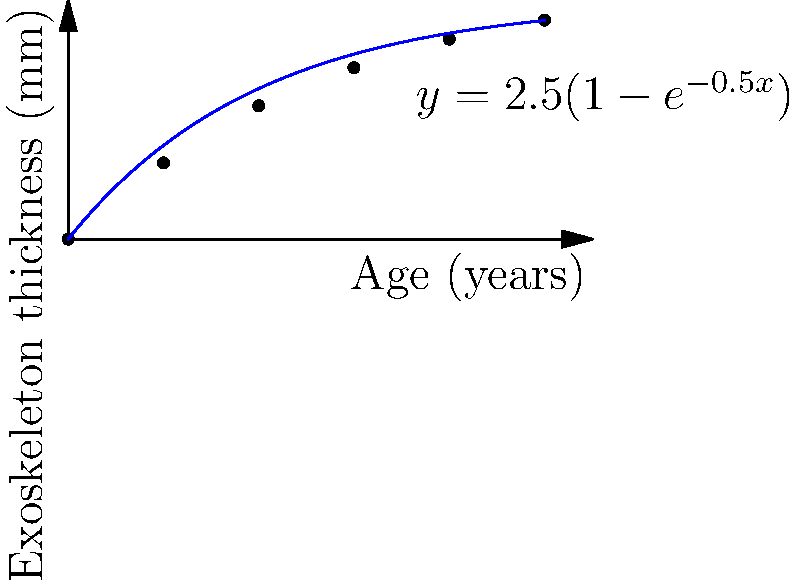Based on the graph showing the relationship between exoskeleton thickness and age in a preserved insect species, estimate the age of a specimen with an exoskeleton thickness of 1.6 mm. To estimate the age of the specimen, we need to follow these steps:

1. The graph shows a relationship between exoskeleton thickness (y-axis) and age (x-axis) for a preserved insect species.

2. The relationship is modeled by the equation $y = 2.5(1-e^{-0.5x})$, where $y$ is the exoskeleton thickness in mm and $x$ is the age in years.

3. We need to find $x$ when $y = 1.6$ mm.

4. Substituting the known values into the equation:
   $1.6 = 2.5(1-e^{-0.5x})$

5. Solving for $x$:
   $\frac{1.6}{2.5} = 1-e^{-0.5x}$
   $0.64 = 1-e^{-0.5x}$
   $e^{-0.5x} = 1-0.64 = 0.36$
   $-0.5x = \ln(0.36)$
   $x = -\frac{2\ln(0.36)}{1} \approx 2.04$

6. Therefore, the estimated age of the specimen is approximately 2.04 years.

7. We can verify this visually on the graph by finding where the horizontal line at y = 1.6 mm intersects the curve, which is slightly after the 2-year mark on the x-axis.
Answer: 2.04 years 